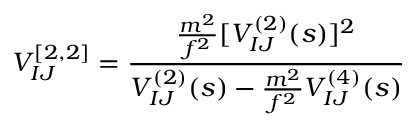<formula> <loc_0><loc_0><loc_500><loc_500>V _ { I J } ^ { [ 2 , 2 ] } = { \frac { \frac { m ^ { 2 } } { f ^ { 2 } } [ V _ { I J } ^ { ( 2 ) } ( s ) ] ^ { 2 } } { V _ { I J } ^ { ( 2 ) } ( s ) - \frac { m ^ { 2 } } { f ^ { 2 } } V _ { I J } ^ { ( 4 ) } ( s ) } }</formula> 